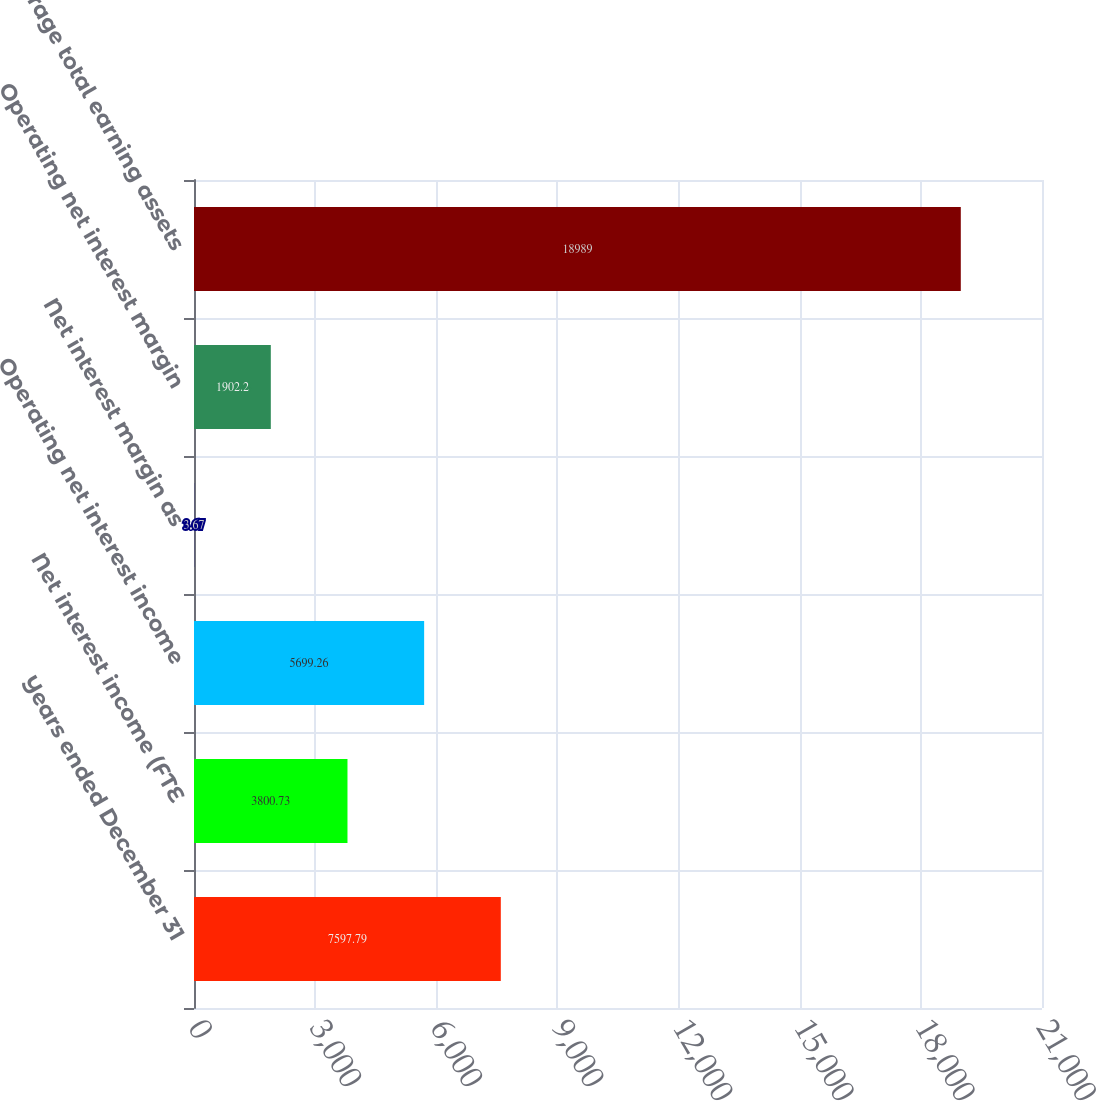<chart> <loc_0><loc_0><loc_500><loc_500><bar_chart><fcel>Years ended December 31<fcel>Net interest income (FTE<fcel>Operating net interest income<fcel>Net interest margin as<fcel>Operating net interest margin<fcel>Average total earning assets<nl><fcel>7597.79<fcel>3800.73<fcel>5699.26<fcel>3.67<fcel>1902.2<fcel>18989<nl></chart> 